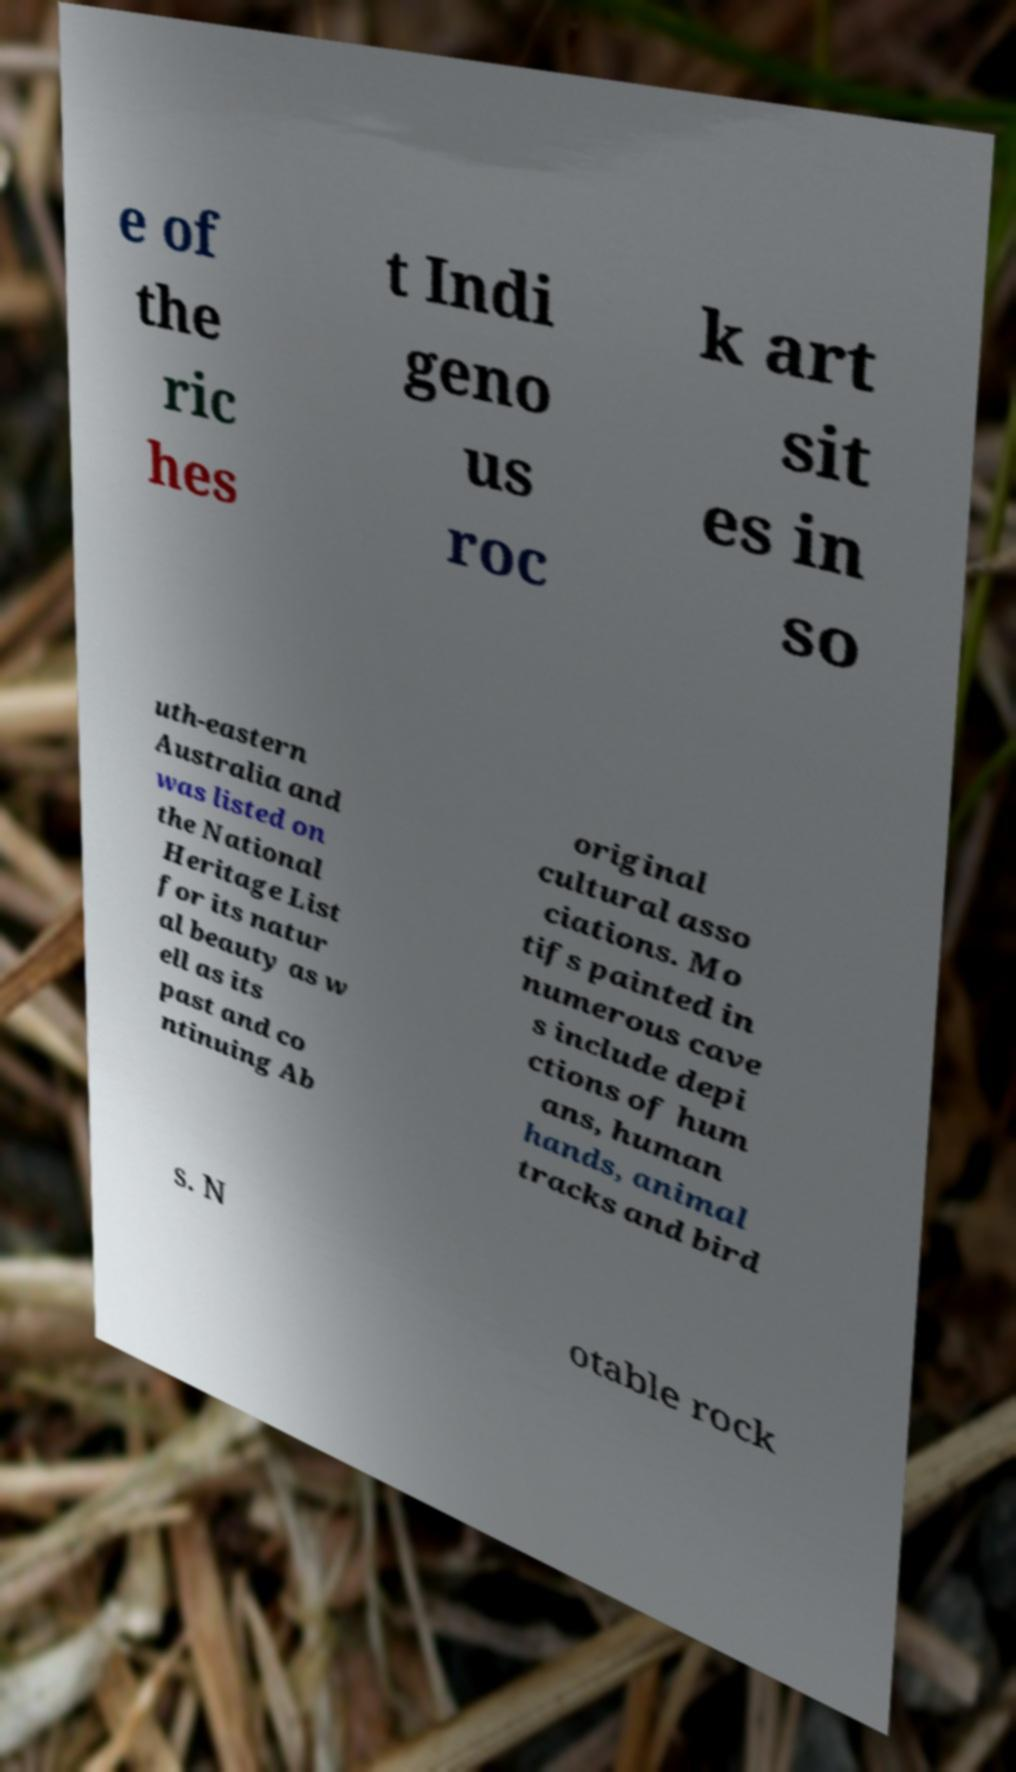There's text embedded in this image that I need extracted. Can you transcribe it verbatim? e of the ric hes t Indi geno us roc k art sit es in so uth-eastern Australia and was listed on the National Heritage List for its natur al beauty as w ell as its past and co ntinuing Ab original cultural asso ciations. Mo tifs painted in numerous cave s include depi ctions of hum ans, human hands, animal tracks and bird s. N otable rock 